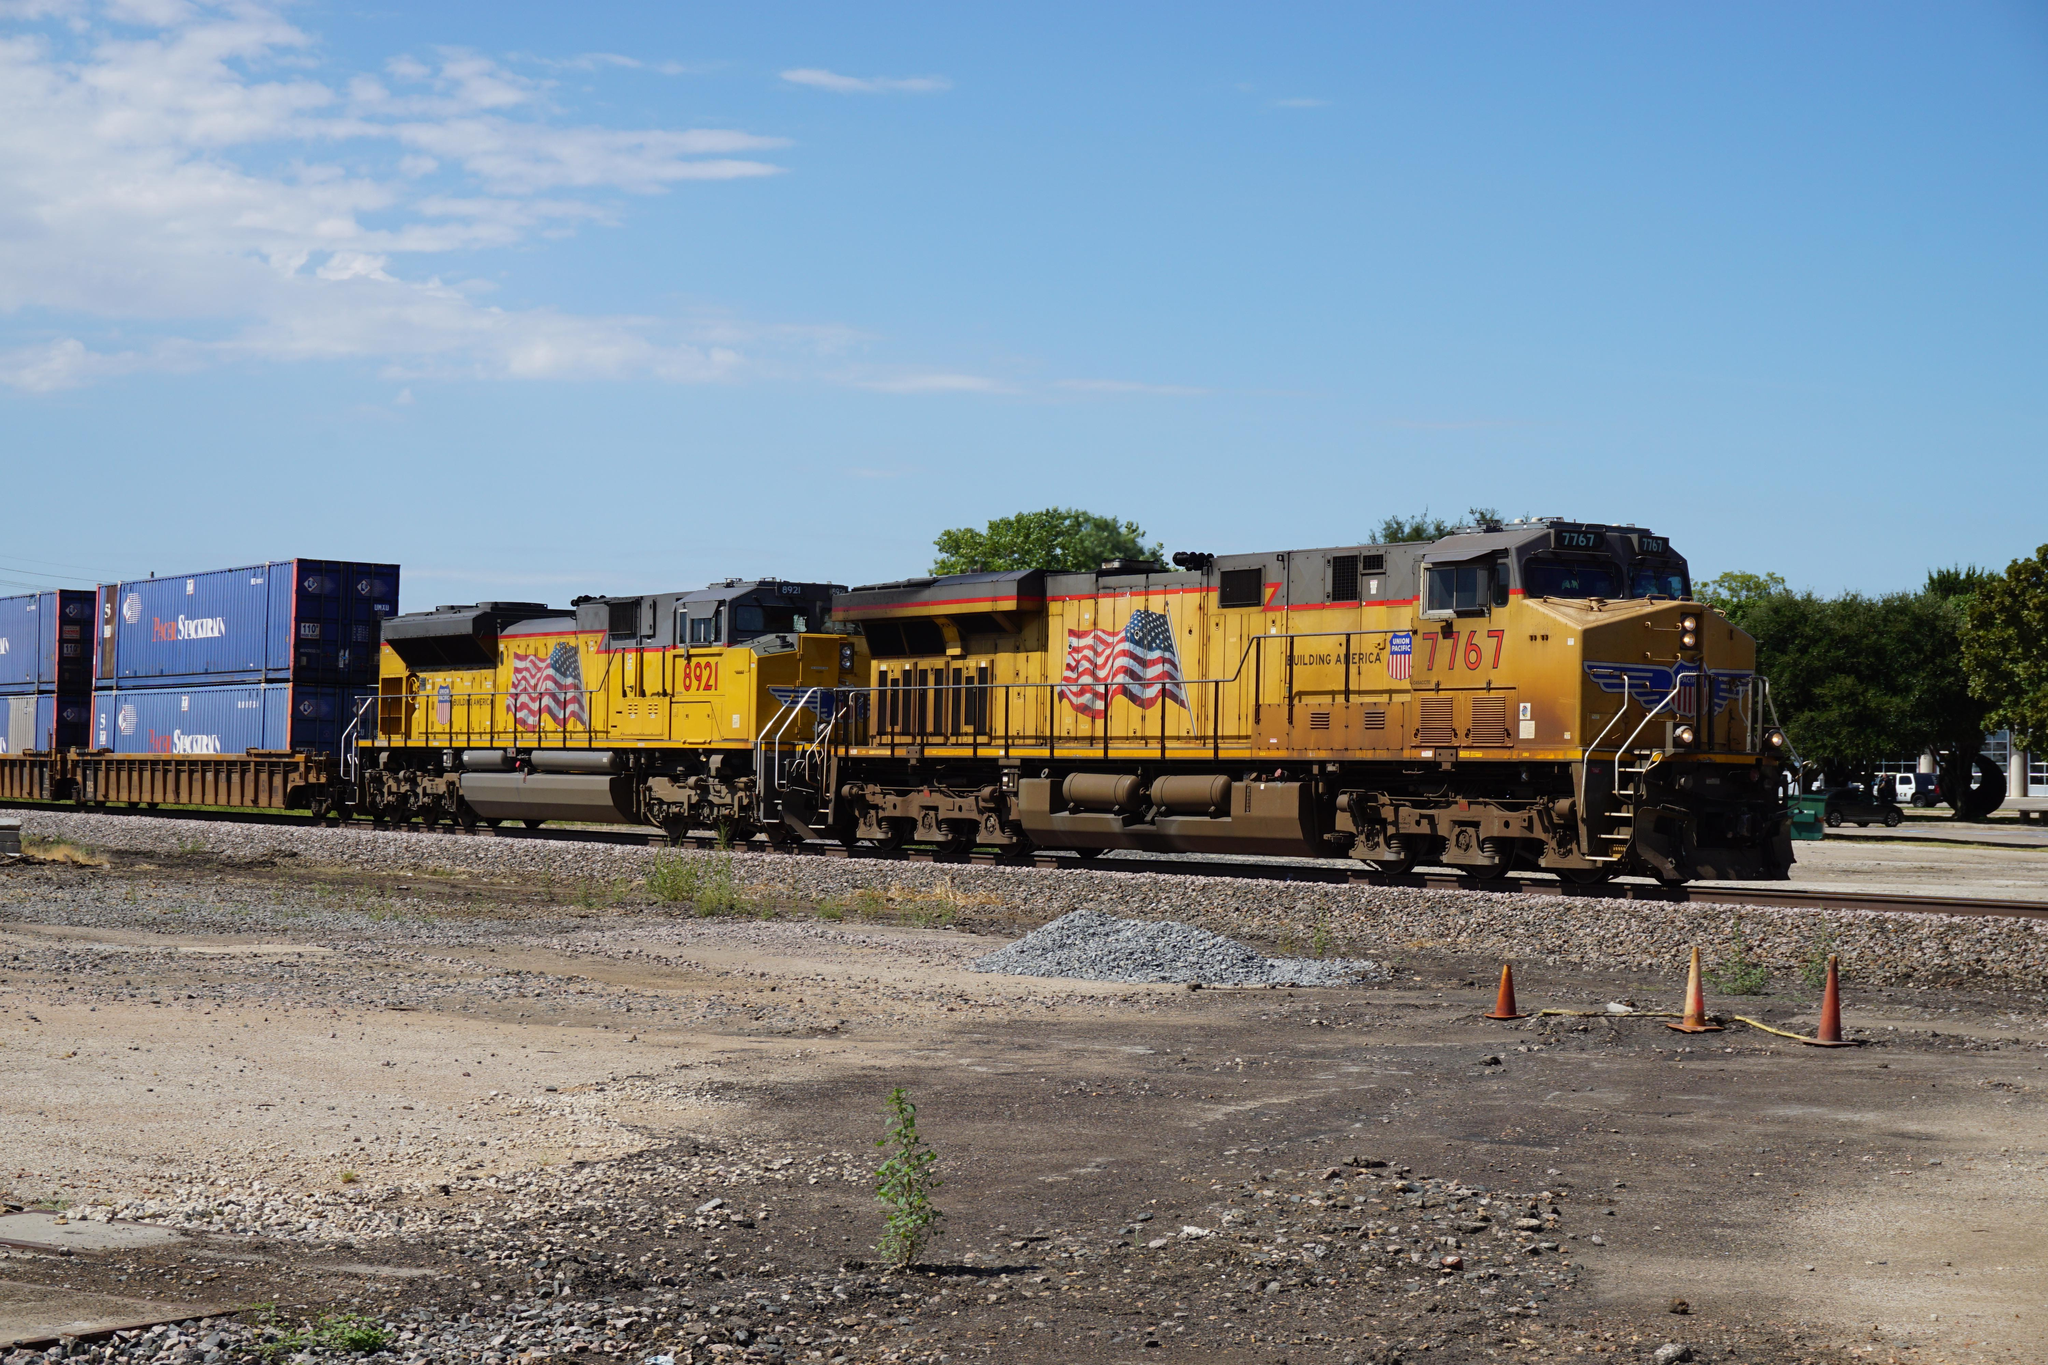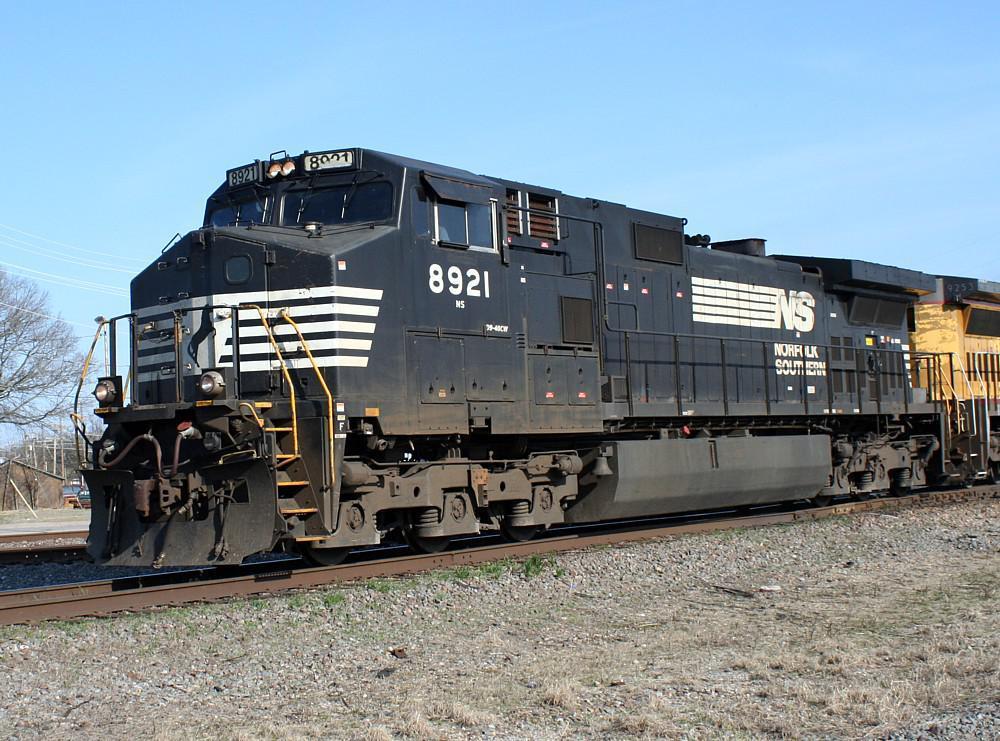The first image is the image on the left, the second image is the image on the right. Examine the images to the left and right. Is the description "There are two trains moving towards the right." accurate? Answer yes or no. No. 